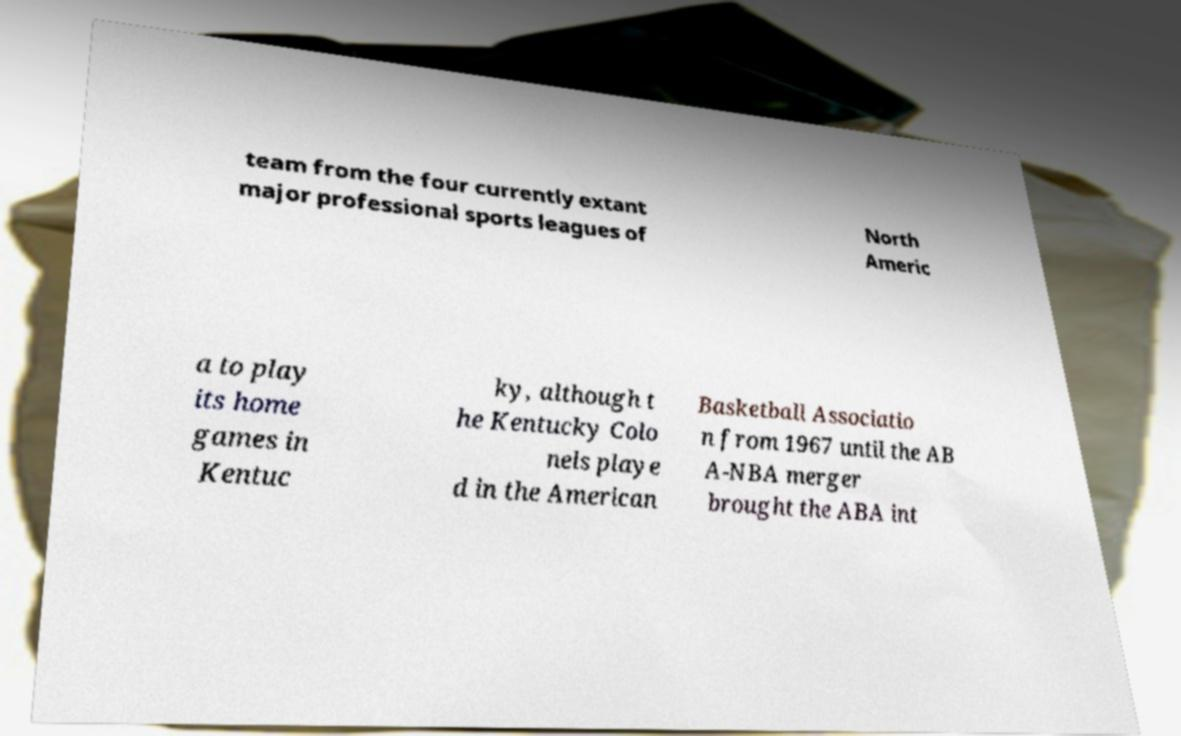For documentation purposes, I need the text within this image transcribed. Could you provide that? team from the four currently extant major professional sports leagues of North Americ a to play its home games in Kentuc ky, although t he Kentucky Colo nels playe d in the American Basketball Associatio n from 1967 until the AB A-NBA merger brought the ABA int 